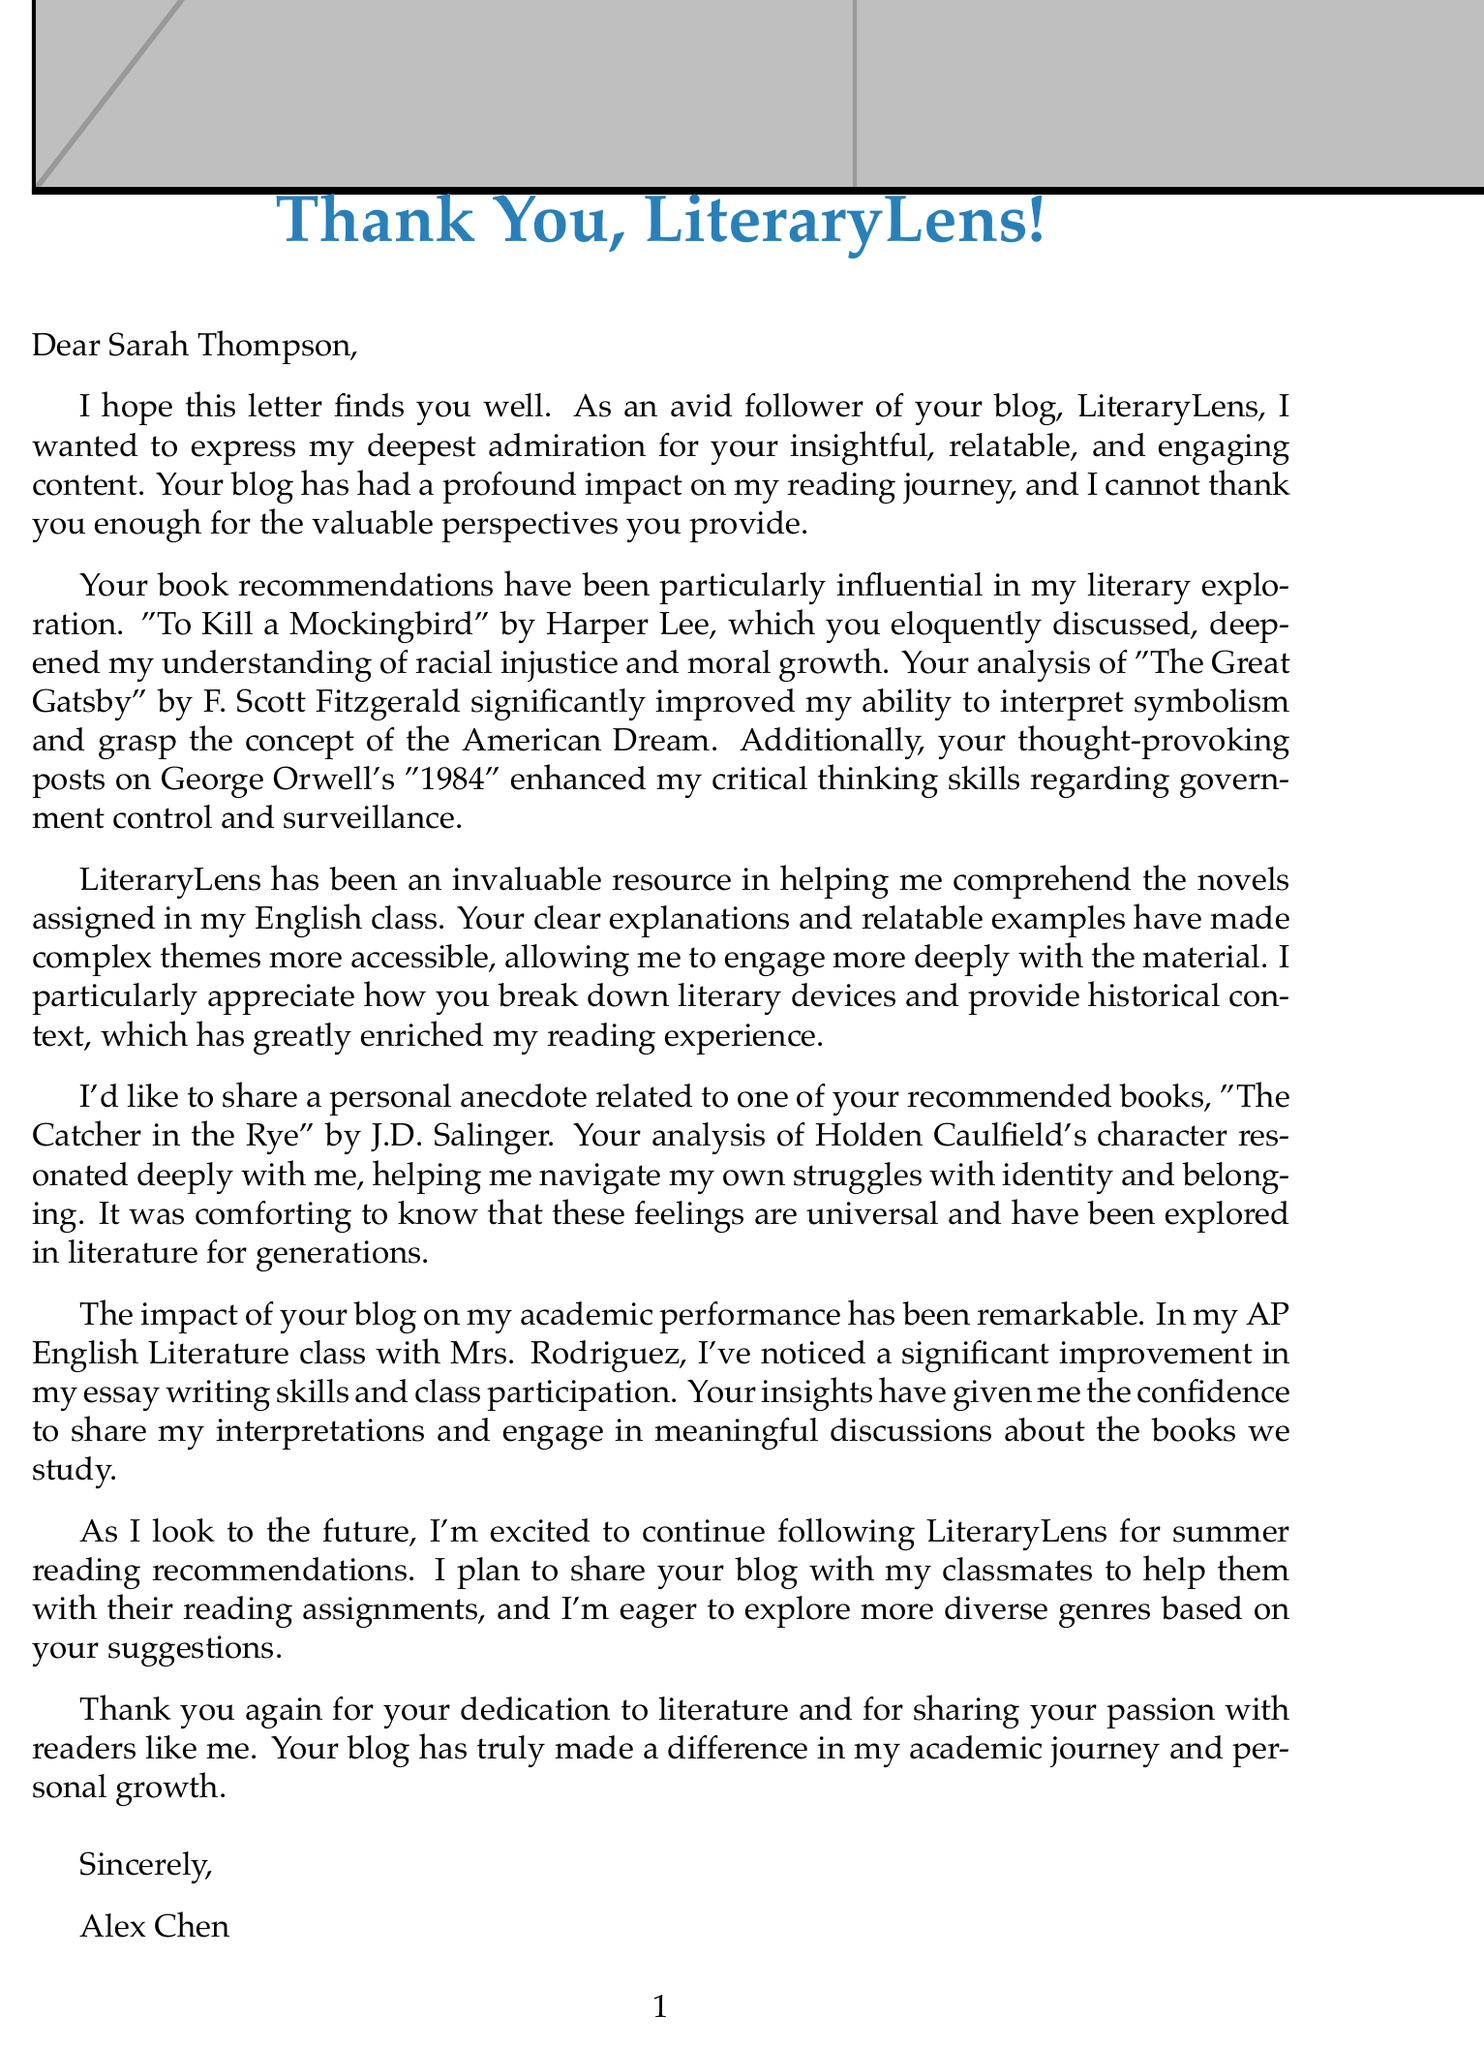What is the name of the blog? The blog is mentioned as "LiteraryLens" in the document.
Answer: LiteraryLens Who is the blogger's name? The document states that the blogger's name is Sarah Thompson.
Answer: Sarah Thompson Which book helped deepen the understanding of racial injustice? The letter specifies that "To Kill a Mockingbird" by Harper Lee addressed racial injustice.
Answer: To Kill a Mockingbird What grade is the student in? The document indicates that the student, Alex Chen, is in the 11th grade.
Answer: 11th Grade What is the name of the English teacher mentioned? The student's AP English Literature teacher is identified as Mrs. Rodriguez.
Answer: Mrs. Rodriguez Which book resonated with the student regarding struggles with identity? The letter mentions "The Catcher in the Rye" by J.D. Salinger in this context.
Answer: The Catcher in the Rye What is one intention the student has for the future? The document mentions that the student plans to continue following the blog for summer reading recommendations.
Answer: Continue following the blog What subject does the student report improvement in? The student notes an improvement in their skills in AP English Literature.
Answer: AP English Literature What is the student's name? The document states the student's name is Alex Chen.
Answer: Alex Chen 